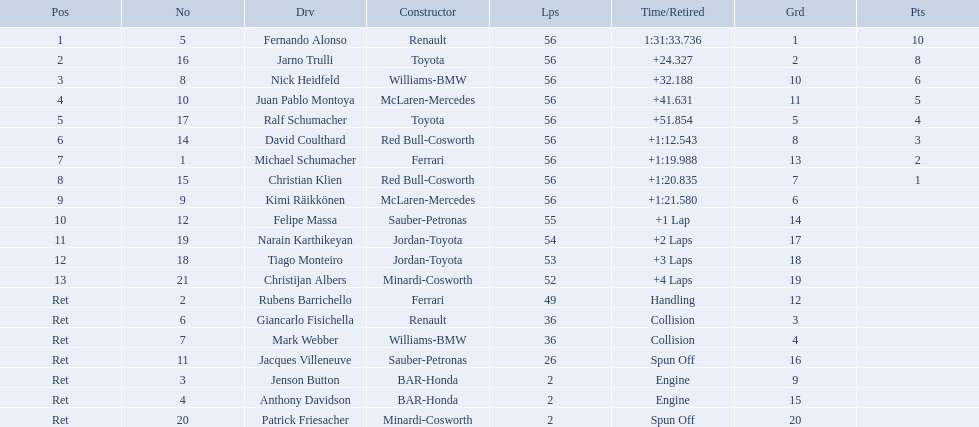Who was fernando alonso's instructor? Renault. How many laps did fernando alonso run? 56. How long did it take alonso to complete the race? 1:31:33.736. What place did fernando alonso finish? 1. How long did it take alonso to finish the race? 1:31:33.736. 